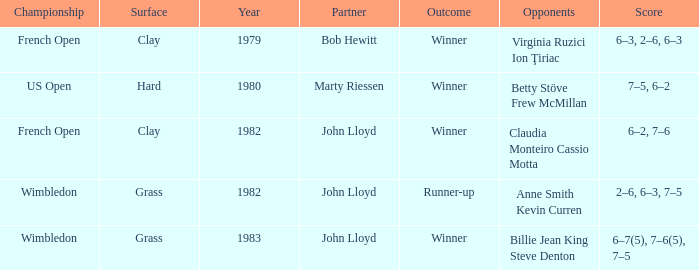What was the total number of matches that had an outcome of Winner, a partner of John Lloyd, and a clay surface? 1.0. 